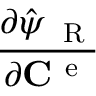<formula> <loc_0><loc_0><loc_500><loc_500>\frac { \partial \hat { \psi } _ { R } } { \partial { { C } ^ { e } } }</formula> 